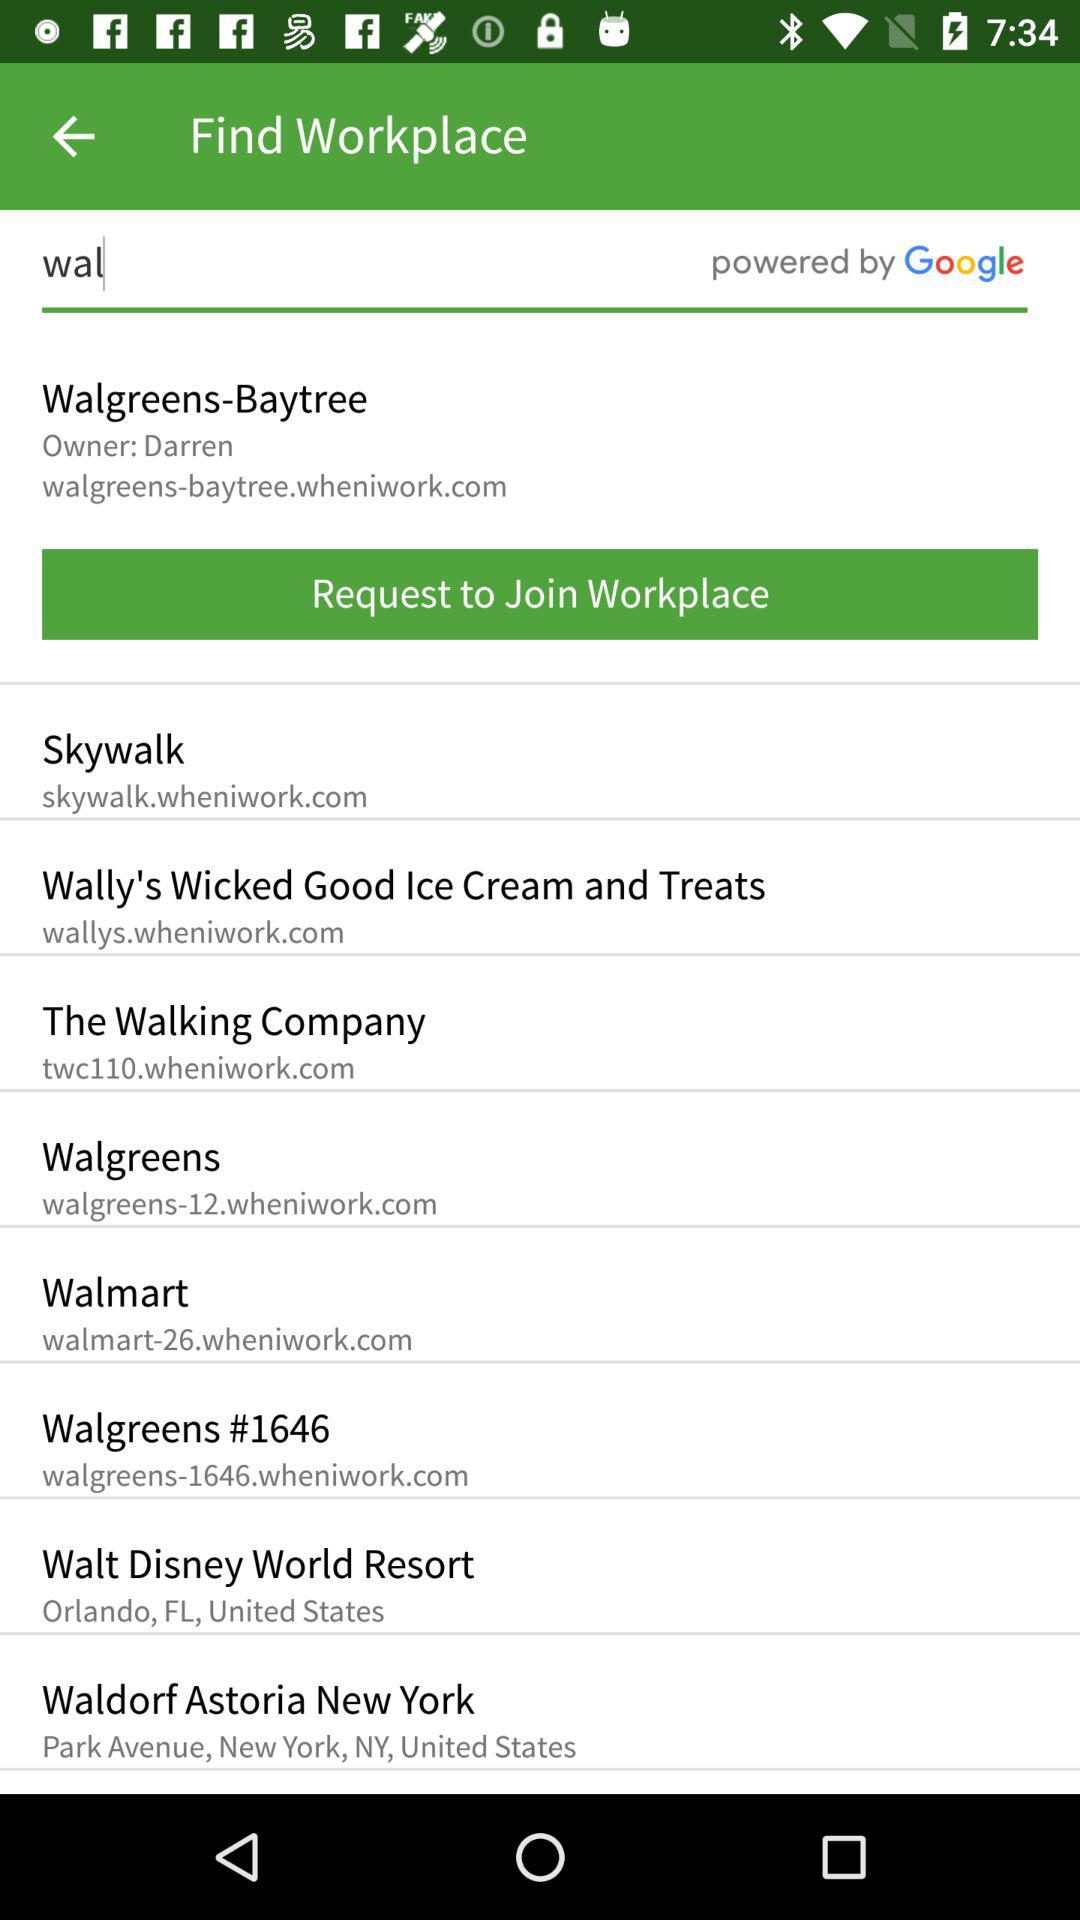Who is the owner of Walgreens-Baytree? The owner of Walgreens-Baytree is Darren. 